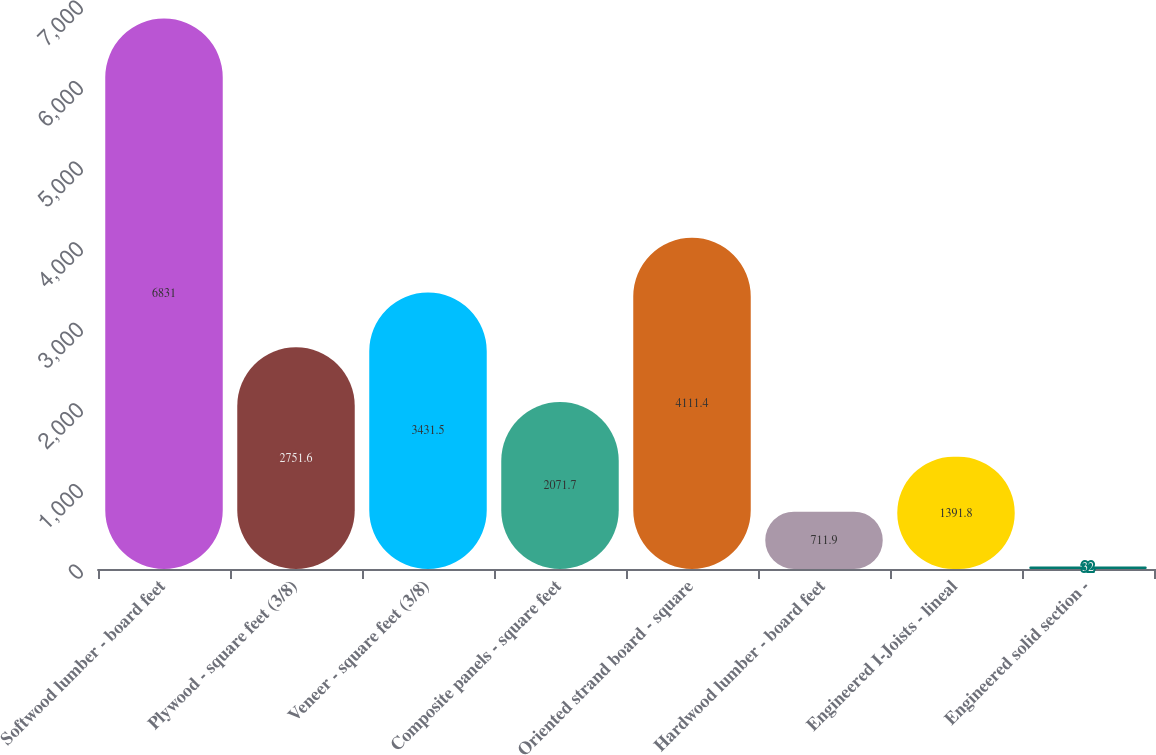Convert chart to OTSL. <chart><loc_0><loc_0><loc_500><loc_500><bar_chart><fcel>Softwood lumber - board feet<fcel>Plywood - square feet (3/8)<fcel>Veneer - square feet (3/8)<fcel>Composite panels - square feet<fcel>Oriented strand board - square<fcel>Hardwood lumber - board feet<fcel>Engineered I-Joists - lineal<fcel>Engineered solid section -<nl><fcel>6831<fcel>2751.6<fcel>3431.5<fcel>2071.7<fcel>4111.4<fcel>711.9<fcel>1391.8<fcel>32<nl></chart> 